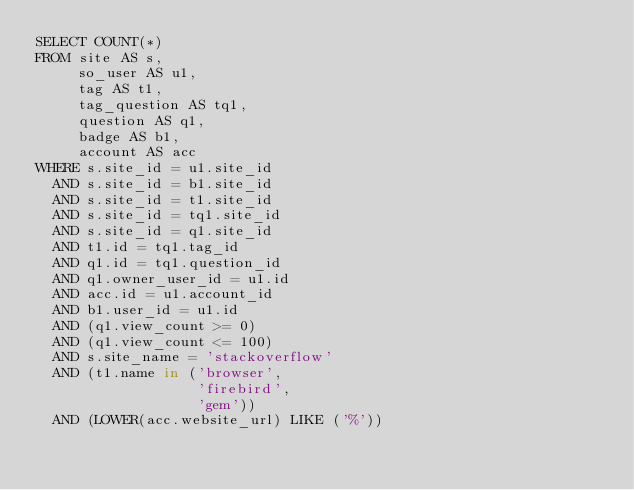Convert code to text. <code><loc_0><loc_0><loc_500><loc_500><_SQL_>SELECT COUNT(*)
FROM site AS s,
     so_user AS u1,
     tag AS t1,
     tag_question AS tq1,
     question AS q1,
     badge AS b1,
     account AS acc
WHERE s.site_id = u1.site_id
  AND s.site_id = b1.site_id
  AND s.site_id = t1.site_id
  AND s.site_id = tq1.site_id
  AND s.site_id = q1.site_id
  AND t1.id = tq1.tag_id
  AND q1.id = tq1.question_id
  AND q1.owner_user_id = u1.id
  AND acc.id = u1.account_id
  AND b1.user_id = u1.id
  AND (q1.view_count >= 0)
  AND (q1.view_count <= 100)
  AND s.site_name = 'stackoverflow'
  AND (t1.name in ('browser',
                   'firebird',
                   'gem'))
  AND (LOWER(acc.website_url) LIKE ('%'))</code> 